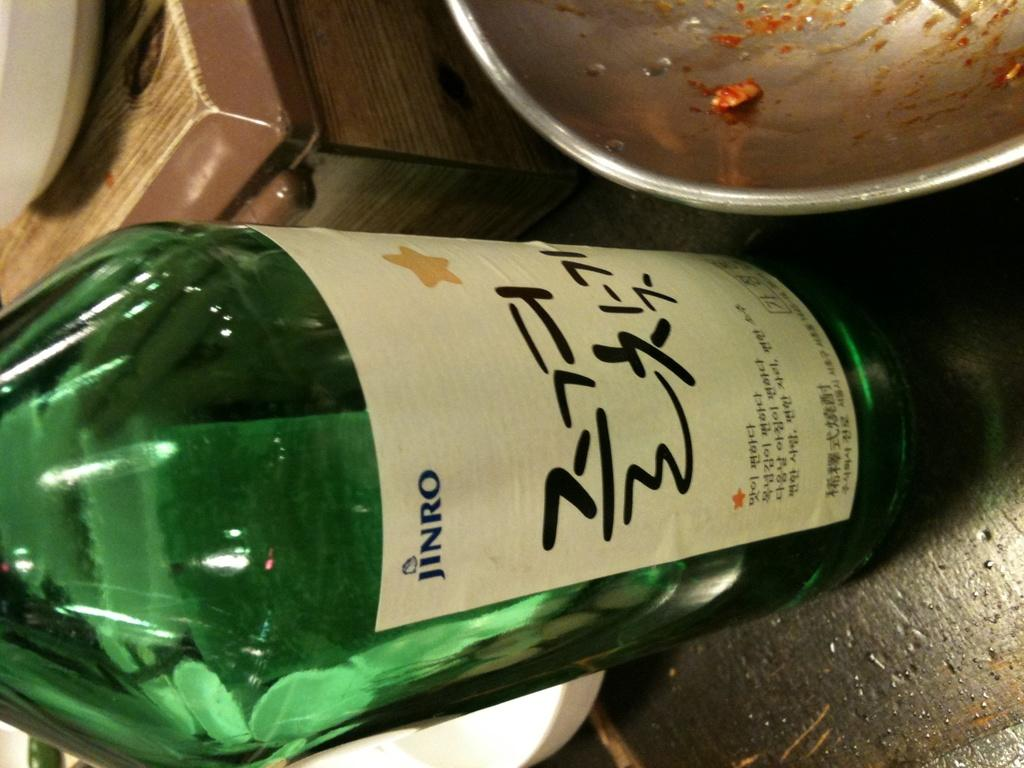<image>
Relay a brief, clear account of the picture shown. a green bottle with a label that says jinro on it 